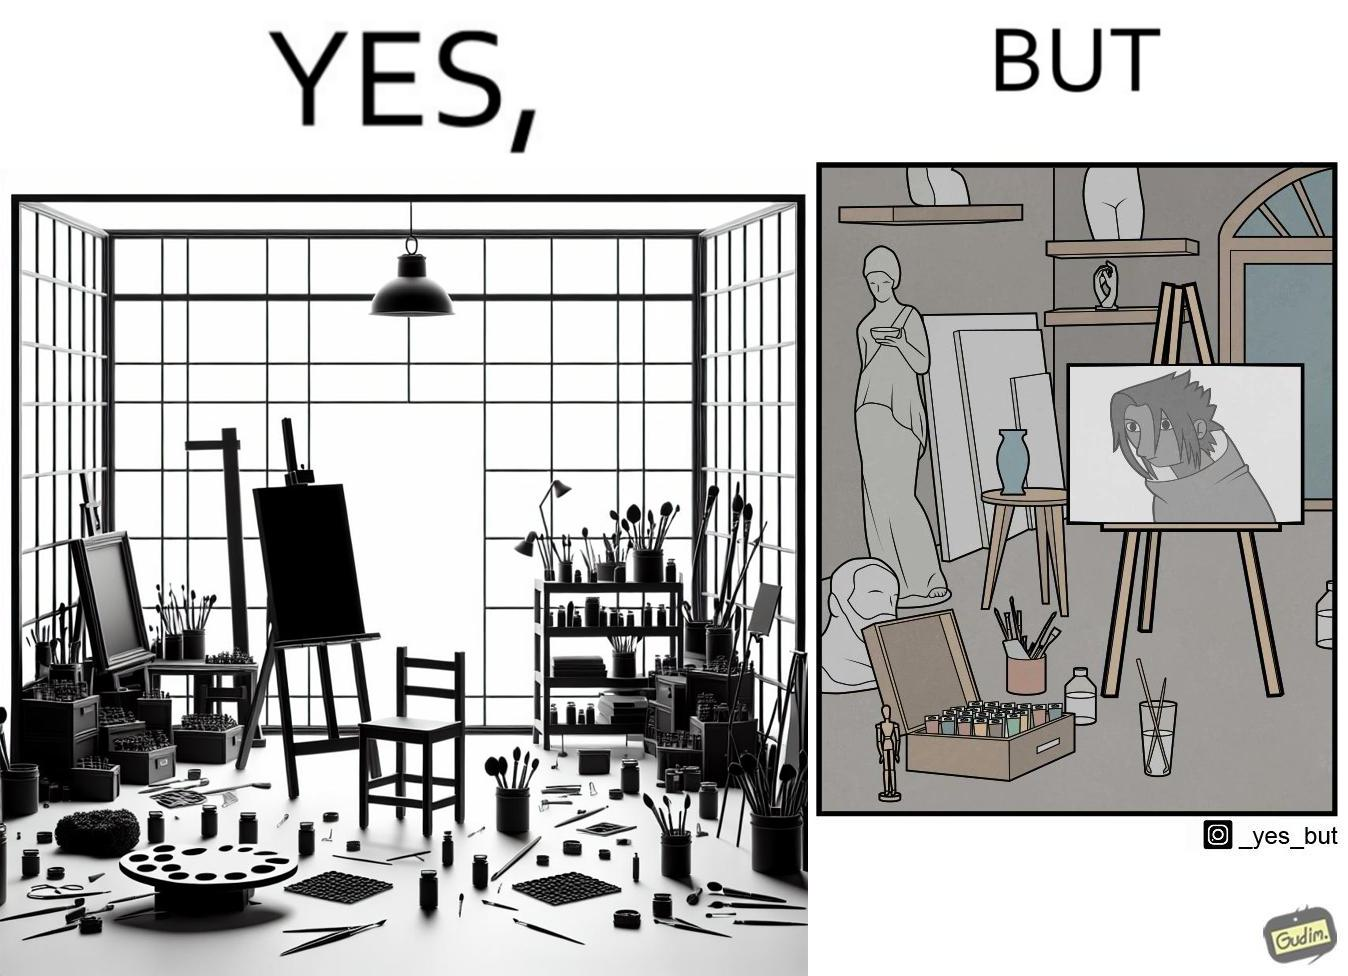Explain why this image is satirical. The image is ironical, as even though the art studio contains a palette of a range of color paints, the painting on the canvas is black and white. 